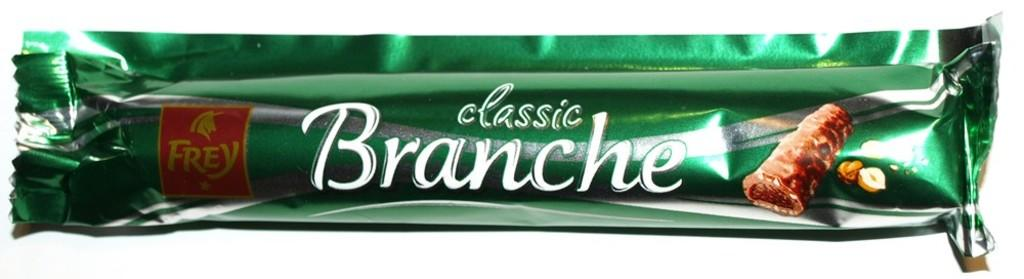<image>
Summarize the visual content of the image. the green packaging of a classic branche chocolate bar 